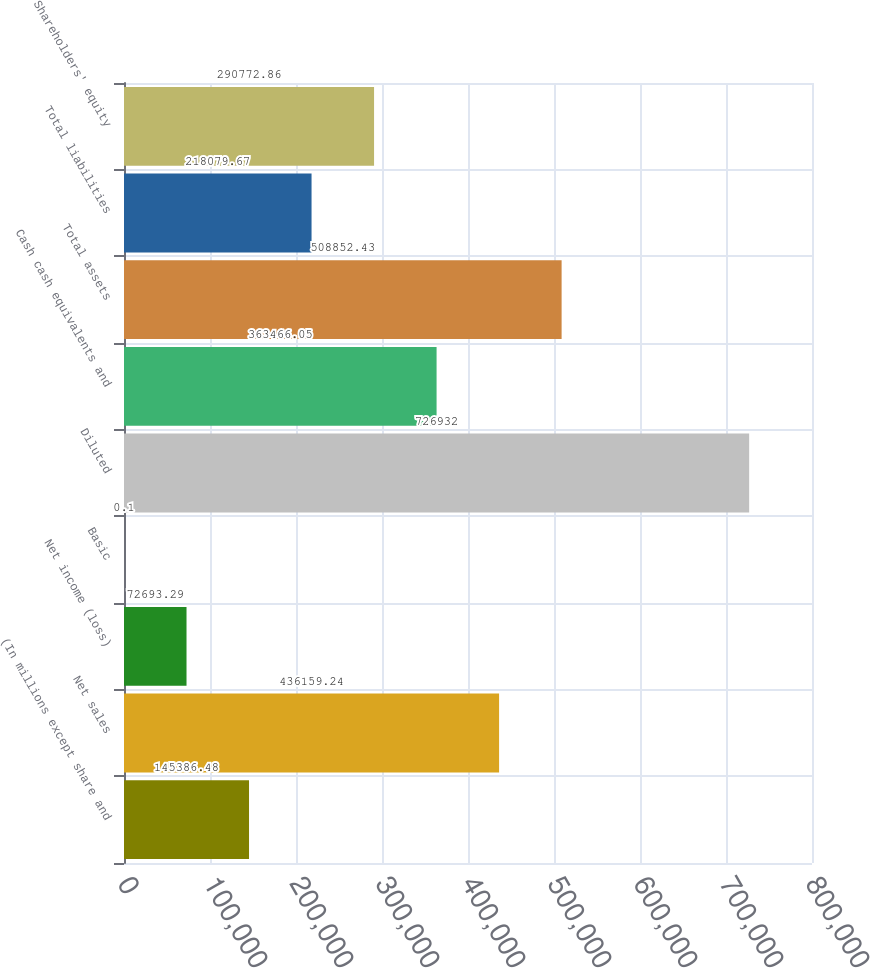Convert chart. <chart><loc_0><loc_0><loc_500><loc_500><bar_chart><fcel>(In millions except share and<fcel>Net sales<fcel>Net income (loss)<fcel>Basic<fcel>Diluted<fcel>Cash cash equivalents and<fcel>Total assets<fcel>Total liabilities<fcel>Shareholders' equity<nl><fcel>145386<fcel>436159<fcel>72693.3<fcel>0.1<fcel>726932<fcel>363466<fcel>508852<fcel>218080<fcel>290773<nl></chart> 